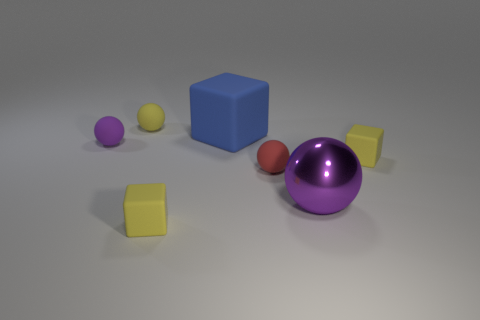How many large metallic objects are the same shape as the big blue matte thing?
Your response must be concise. 0. Is the number of yellow balls behind the big purple metallic object less than the number of blue cubes in front of the tiny purple rubber ball?
Provide a short and direct response. No. There is a tiny yellow ball left of the large purple ball; what number of tiny yellow cubes are behind it?
Your answer should be compact. 0. Are there any large blue cubes?
Your response must be concise. Yes. Are there any big yellow spheres made of the same material as the blue cube?
Offer a very short reply. No. Are there more yellow matte balls that are in front of the big purple sphere than yellow cubes left of the red matte ball?
Make the answer very short. No. Does the yellow rubber sphere have the same size as the metal sphere?
Provide a succinct answer. No. The matte sphere right of the yellow rubber cube that is to the left of the blue rubber thing is what color?
Ensure brevity in your answer.  Red. The large metallic ball is what color?
Provide a short and direct response. Purple. Is there a small sphere of the same color as the large matte object?
Keep it short and to the point. No. 